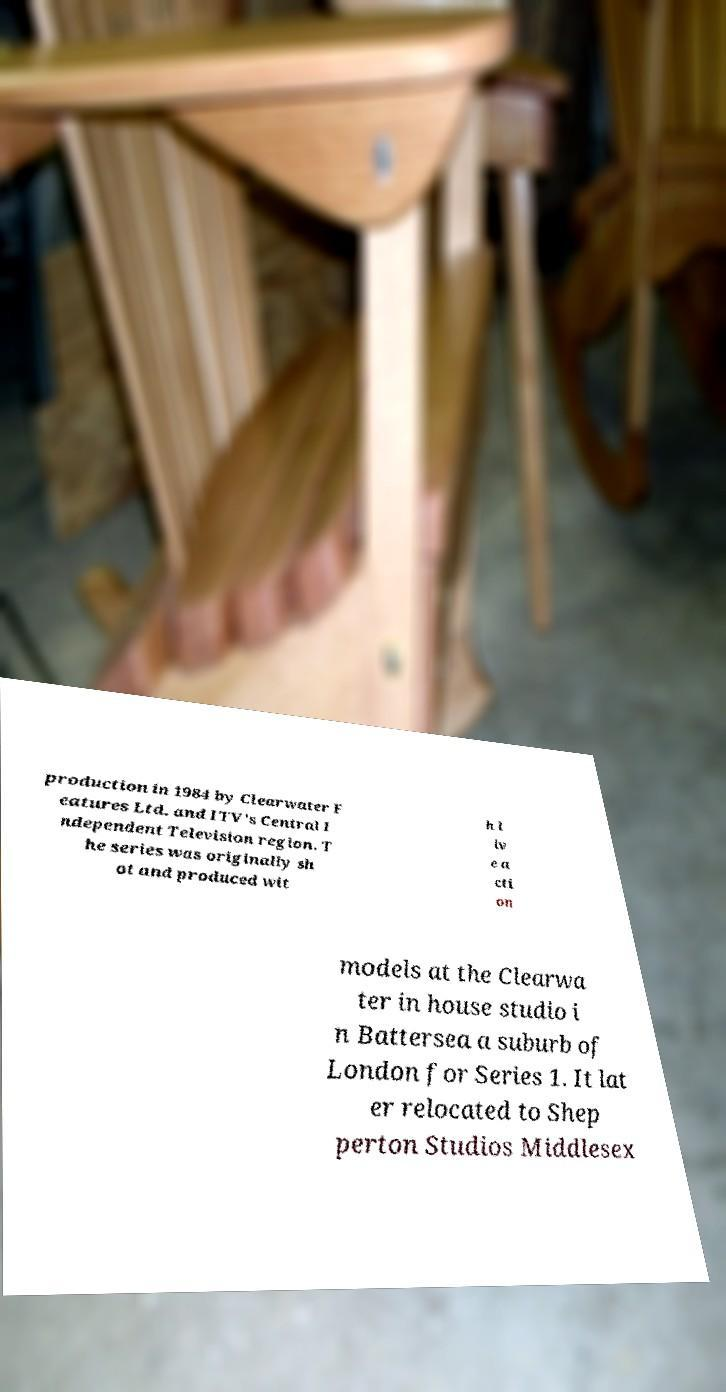What messages or text are displayed in this image? I need them in a readable, typed format. production in 1984 by Clearwater F eatures Ltd. and ITV's Central I ndependent Television region. T he series was originally sh ot and produced wit h l iv e a cti on models at the Clearwa ter in house studio i n Battersea a suburb of London for Series 1. It lat er relocated to Shep perton Studios Middlesex 